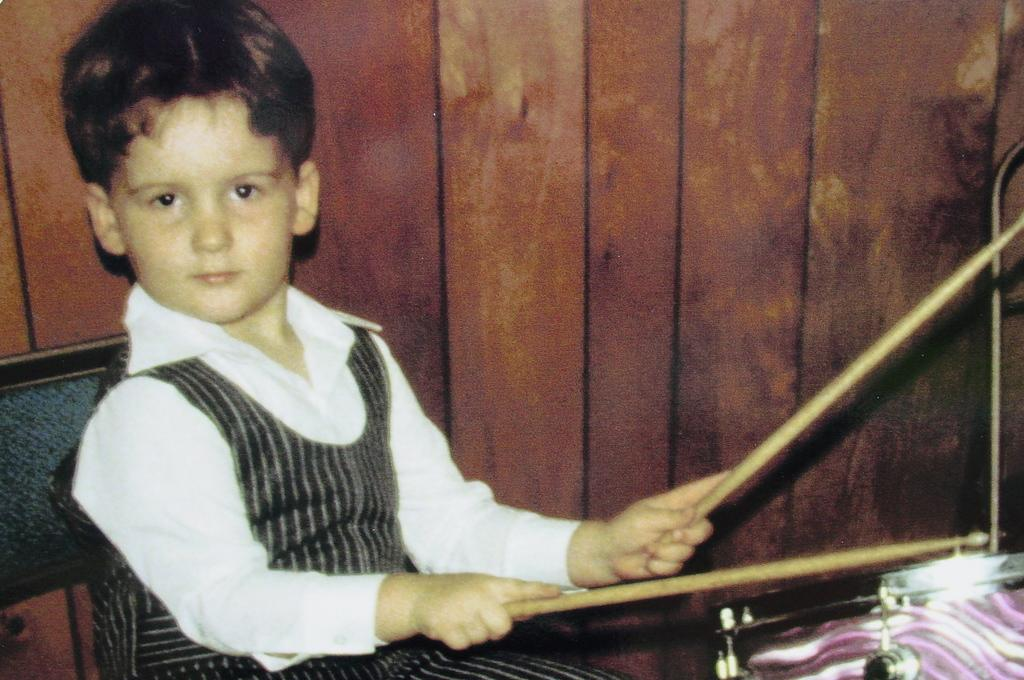Who is in the image? There is a boy in the image. What is the boy holding in his hands? The boy is holding sticks in his hands. What musical instrument is in the image? There is a drum in the image. What is the boy sitting on? The boy is sitting on a chair. What can be seen in the background of the image? There is a wall in the background of the image. What type of operation is the boy performing on the corn in the image? There is no corn present in the image, and the boy is not performing any operation. 